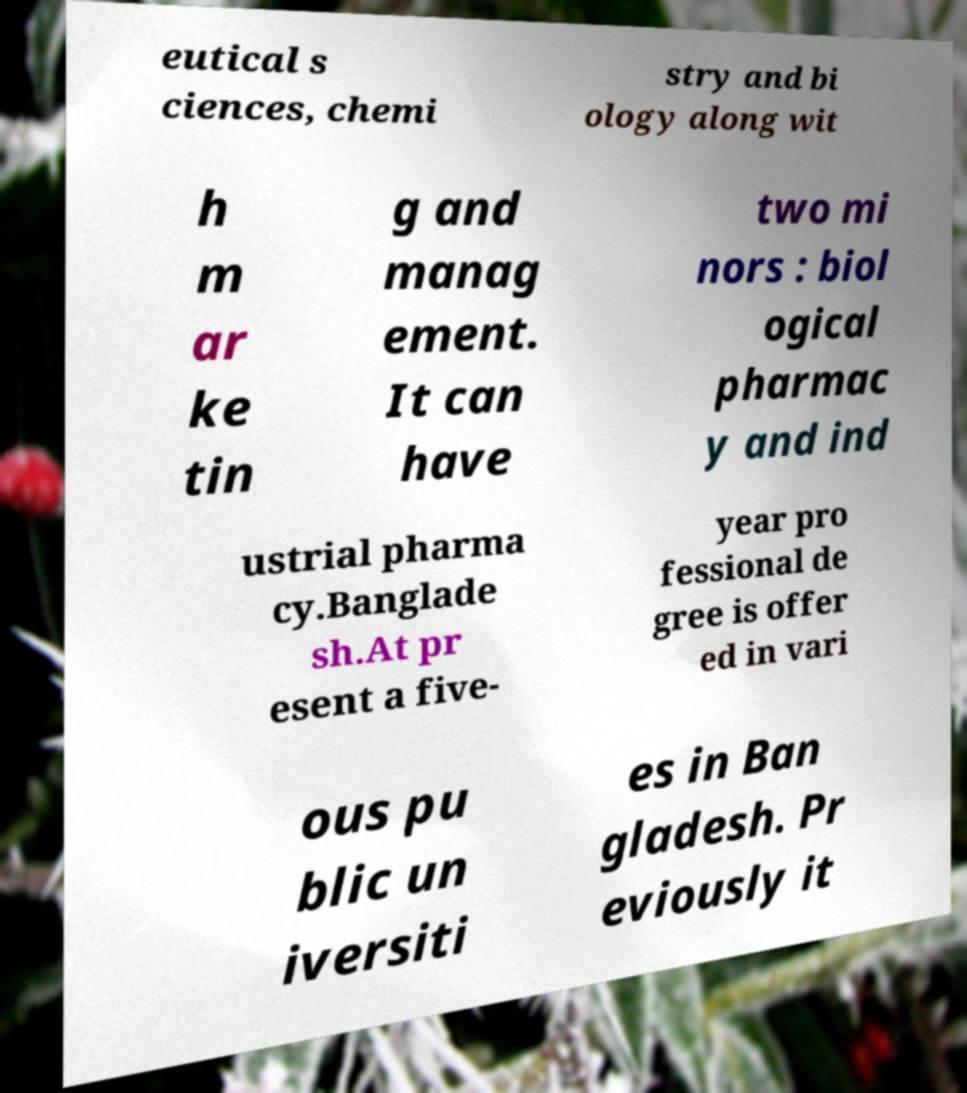I need the written content from this picture converted into text. Can you do that? eutical s ciences, chemi stry and bi ology along wit h m ar ke tin g and manag ement. It can have two mi nors : biol ogical pharmac y and ind ustrial pharma cy.Banglade sh.At pr esent a five- year pro fessional de gree is offer ed in vari ous pu blic un iversiti es in Ban gladesh. Pr eviously it 